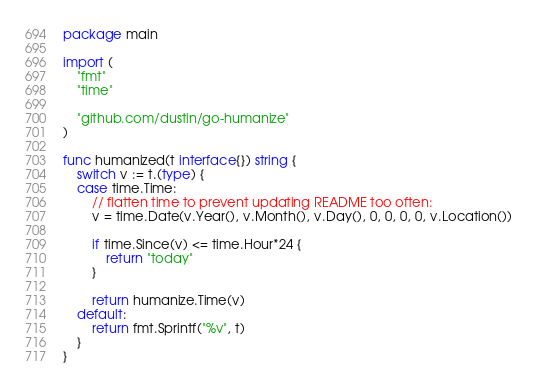Convert code to text. <code><loc_0><loc_0><loc_500><loc_500><_Go_>package main

import (
	"fmt"
	"time"

	"github.com/dustin/go-humanize"
)

func humanized(t interface{}) string {
	switch v := t.(type) {
	case time.Time:
		// flatten time to prevent updating README too often:
		v = time.Date(v.Year(), v.Month(), v.Day(), 0, 0, 0, 0, v.Location())

		if time.Since(v) <= time.Hour*24 {
			return "today"
		}

		return humanize.Time(v)
	default:
		return fmt.Sprintf("%v", t)
	}
}
</code> 